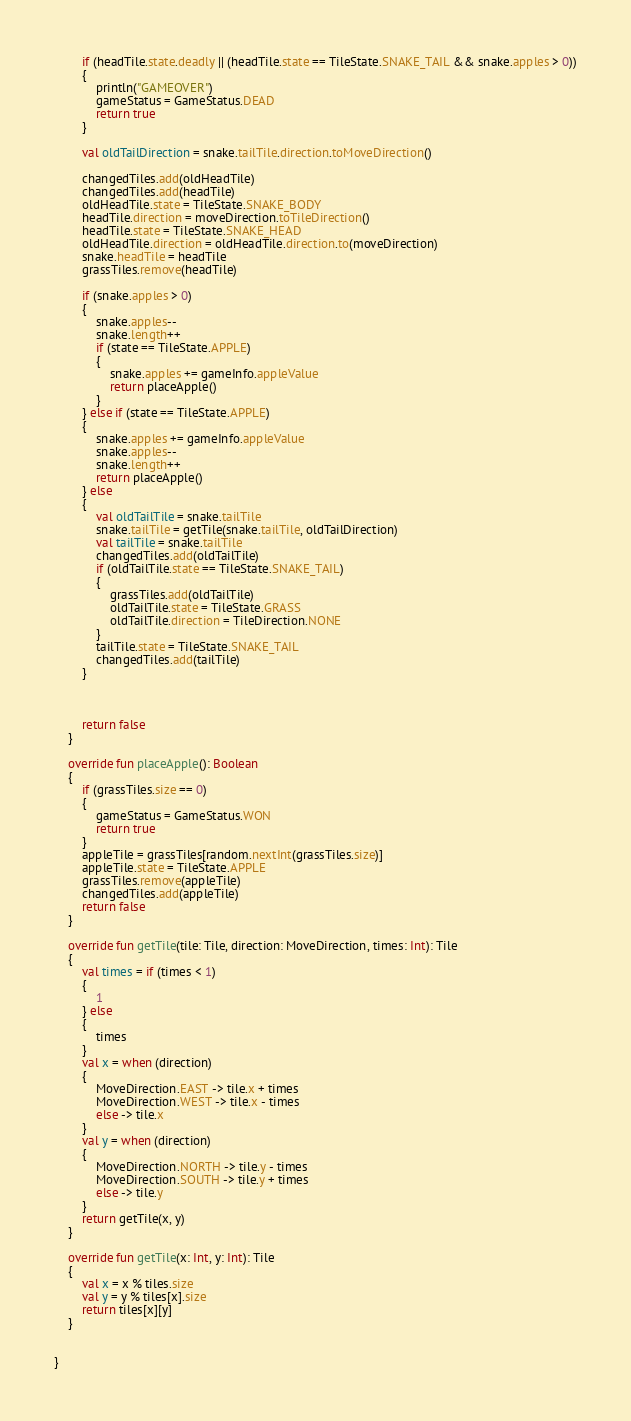Convert code to text. <code><loc_0><loc_0><loc_500><loc_500><_Kotlin_>        if (headTile.state.deadly || (headTile.state == TileState.SNAKE_TAIL && snake.apples > 0))
        {
            println("GAMEOVER")
            gameStatus = GameStatus.DEAD
            return true
        }

        val oldTailDirection = snake.tailTile.direction.toMoveDirection()

        changedTiles.add(oldHeadTile)
        changedTiles.add(headTile)
        oldHeadTile.state = TileState.SNAKE_BODY
        headTile.direction = moveDirection.toTileDirection()
        headTile.state = TileState.SNAKE_HEAD
        oldHeadTile.direction = oldHeadTile.direction.to(moveDirection)
        snake.headTile = headTile
        grassTiles.remove(headTile)

        if (snake.apples > 0)
        {
            snake.apples--
            snake.length++
            if (state == TileState.APPLE)
            {
                snake.apples += gameInfo.appleValue
                return placeApple()
            }
        } else if (state == TileState.APPLE)
        {
            snake.apples += gameInfo.appleValue
            snake.apples--
            snake.length++
            return placeApple()
        } else
        {
            val oldTailTile = snake.tailTile
            snake.tailTile = getTile(snake.tailTile, oldTailDirection)
            val tailTile = snake.tailTile
            changedTiles.add(oldTailTile)
            if (oldTailTile.state == TileState.SNAKE_TAIL)
            {
                grassTiles.add(oldTailTile)
                oldTailTile.state = TileState.GRASS
                oldTailTile.direction = TileDirection.NONE
            }
            tailTile.state = TileState.SNAKE_TAIL
            changedTiles.add(tailTile)
        }



        return false
    }

    override fun placeApple(): Boolean
    {
        if (grassTiles.size == 0)
        {
            gameStatus = GameStatus.WON
            return true
        }
        appleTile = grassTiles[random.nextInt(grassTiles.size)]
        appleTile.state = TileState.APPLE
        grassTiles.remove(appleTile)
        changedTiles.add(appleTile)
        return false
    }

    override fun getTile(tile: Tile, direction: MoveDirection, times: Int): Tile
    {
        val times = if (times < 1)
        {
            1
        } else
        {
            times
        }
        val x = when (direction)
        {
            MoveDirection.EAST -> tile.x + times
            MoveDirection.WEST -> tile.x - times
            else -> tile.x
        }
        val y = when (direction)
        {
            MoveDirection.NORTH -> tile.y - times
            MoveDirection.SOUTH -> tile.y + times
            else -> tile.y
        }
        return getTile(x, y)
    }

    override fun getTile(x: Int, y: Int): Tile
    {
        val x = x % tiles.size
        val y = y % tiles[x].size
        return tiles[x][y]
    }


}
</code> 